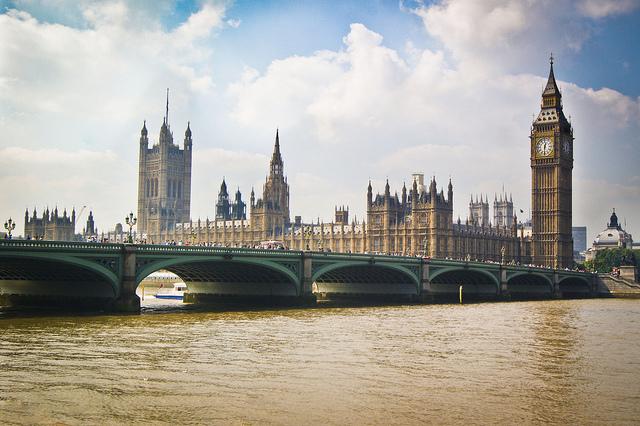What is under the bridge?
Short answer required. Water. Is the building a castle?
Keep it brief. Yes. What is on the water?
Short answer required. Bridge. How many clocks are shown?
Quick response, please. 1. 